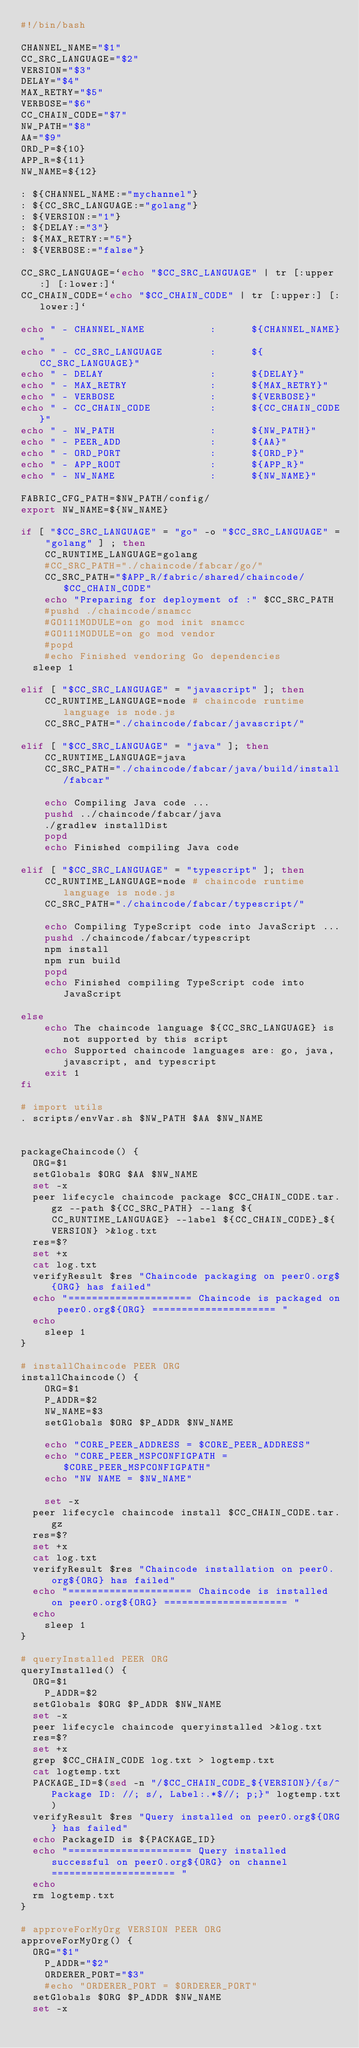<code> <loc_0><loc_0><loc_500><loc_500><_Bash_>#!/bin/bash

CHANNEL_NAME="$1"
CC_SRC_LANGUAGE="$2"
VERSION="$3"
DELAY="$4"
MAX_RETRY="$5"
VERBOSE="$6"
CC_CHAIN_CODE="$7"
NW_PATH="$8"
AA="$9"
ORD_P=${10}
APP_R=${11}
NW_NAME=${12}

: ${CHANNEL_NAME:="mychannel"}
: ${CC_SRC_LANGUAGE:="golang"}
: ${VERSION:="1"}
: ${DELAY:="3"}
: ${MAX_RETRY:="5"}
: ${VERBOSE:="false"}

CC_SRC_LANGUAGE=`echo "$CC_SRC_LANGUAGE" | tr [:upper:] [:lower:]`
CC_CHAIN_CODE=`echo "$CC_CHAIN_CODE" | tr [:upper:] [:lower:]`

echo " - CHANNEL_NAME           :      ${CHANNEL_NAME}"
echo " - CC_SRC_LANGUAGE        :      ${CC_SRC_LANGUAGE}"
echo " - DELAY                  :      ${DELAY}"
echo " - MAX_RETRY              :      ${MAX_RETRY}"
echo " - VERBOSE                :      ${VERBOSE}"
echo " - CC_CHAIN_CODE          :      ${CC_CHAIN_CODE}"
echo " - NW_PATH                :      ${NW_PATH}"
echo " - PEER_ADD               :      ${AA}"
echo " - ORD_PORT               :      ${ORD_P}"
echo " - APP_ROOT               :      ${APP_R}"
echo " - NW_NAME                :      ${NW_NAME}"

FABRIC_CFG_PATH=$NW_PATH/config/
export NW_NAME=${NW_NAME}

if [ "$CC_SRC_LANGUAGE" = "go" -o "$CC_SRC_LANGUAGE" = "golang" ] ; then
	CC_RUNTIME_LANGUAGE=golang
	#CC_SRC_PATH="./chaincode/fabcar/go/"
	CC_SRC_PATH="$APP_R/fabric/shared/chaincode/$CC_CHAIN_CODE"
	echo "Preparing for deployment of :" $CC_SRC_PATH
	#pushd ./chaincode/snamcc
	#GO111MODULE=on go mod init snamcc
	#GO111MODULE=on go mod vendor
	#popd
	#echo Finished vendoring Go dependencies
  sleep 1

elif [ "$CC_SRC_LANGUAGE" = "javascript" ]; then
	CC_RUNTIME_LANGUAGE=node # chaincode runtime language is node.js
	CC_SRC_PATH="./chaincode/fabcar/javascript/"

elif [ "$CC_SRC_LANGUAGE" = "java" ]; then
	CC_RUNTIME_LANGUAGE=java
	CC_SRC_PATH="./chaincode/fabcar/java/build/install/fabcar"

	echo Compiling Java code ...
	pushd ../chaincode/fabcar/java
	./gradlew installDist
	popd
	echo Finished compiling Java code

elif [ "$CC_SRC_LANGUAGE" = "typescript" ]; then
	CC_RUNTIME_LANGUAGE=node # chaincode runtime language is node.js
	CC_SRC_PATH="./chaincode/fabcar/typescript/"

	echo Compiling TypeScript code into JavaScript ...
	pushd ./chaincode/fabcar/typescript
	npm install
	npm run build
	popd
	echo Finished compiling TypeScript code into JavaScript

else
	echo The chaincode language ${CC_SRC_LANGUAGE} is not supported by this script
	echo Supported chaincode languages are: go, java, javascript, and typescript
	exit 1
fi

# import utils
. scripts/envVar.sh $NW_PATH $AA $NW_NAME


packageChaincode() {
  ORG=$1
  setGlobals $ORG $AA $NW_NAME
  set -x
  peer lifecycle chaincode package $CC_CHAIN_CODE.tar.gz --path ${CC_SRC_PATH} --lang ${CC_RUNTIME_LANGUAGE} --label ${CC_CHAIN_CODE}_${VERSION} >&log.txt
  res=$?
  set +x
  cat log.txt
  verifyResult $res "Chaincode packaging on peer0.org${ORG} has failed"
  echo "===================== Chaincode is packaged on peer0.org${ORG} ===================== "
  echo
	sleep 1
}

# installChaincode PEER ORG
installChaincode() {
	ORG=$1
	P_ADDR=$2
	NW_NAME=$3
	setGlobals $ORG $P_ADDR $NW_NAME

	echo "CORE_PEER_ADDRESS = $CORE_PEER_ADDRESS"
	echo "CORE_PEER_MSPCONFIGPATH = $CORE_PEER_MSPCONFIGPATH"
	echo "NW NAME = $NW_NAME"

	set -x
  peer lifecycle chaincode install $CC_CHAIN_CODE.tar.gz
  res=$?
  set +x
  cat log.txt
  verifyResult $res "Chaincode installation on peer0.org${ORG} has failed"
  echo "===================== Chaincode is installed on peer0.org${ORG} ===================== "
  echo
	sleep 1
}

# queryInstalled PEER ORG
queryInstalled() {
  ORG=$1
	P_ADDR=$2
  setGlobals $ORG $P_ADDR $NW_NAME
  set -x
  peer lifecycle chaincode queryinstalled >&log.txt
  res=$?
  set +x
  grep $CC_CHAIN_CODE log.txt > logtemp.txt
  cat logtemp.txt
  PACKAGE_ID=$(sed -n "/$CC_CHAIN_CODE_${VERSION}/{s/^Package ID: //; s/, Label:.*$//; p;}" logtemp.txt)
  verifyResult $res "Query installed on peer0.org${ORG} has failed"
  echo PackageID is ${PACKAGE_ID}
  echo "===================== Query installed successful on peer0.org${ORG} on channel ===================== "
  echo
  rm logtemp.txt
}

# approveForMyOrg VERSION PEER ORG
approveForMyOrg() {
  ORG="$1"
	P_ADDR="$2"
	ORDERER_PORT="$3"
	#echo "ORDERER_PORT = $ORDERER_PORT"
  setGlobals $ORG $P_ADDR $NW_NAME
  set -x</code> 